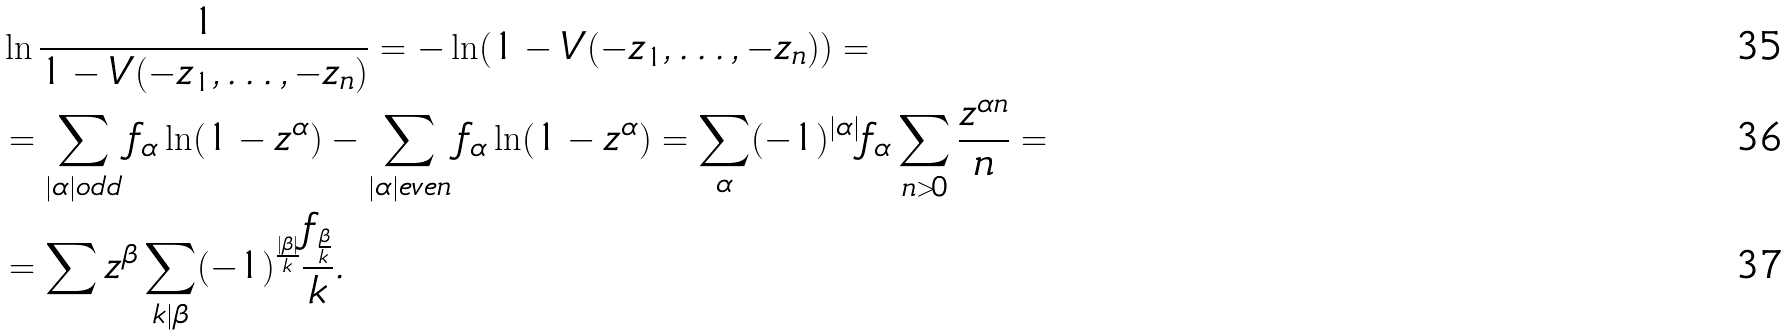Convert formula to latex. <formula><loc_0><loc_0><loc_500><loc_500>& \ln \frac { 1 } { 1 - V ( - z _ { 1 } , \dots , - z _ { n } ) } = - \ln ( 1 - V ( - z _ { 1 } , \dots , - z _ { n } ) ) = \\ & = \sum _ { | \alpha | o d d } f _ { \alpha } \ln ( 1 - z ^ { \alpha } ) - \sum _ { | \alpha | e v e n } f _ { \alpha } \ln ( 1 - z ^ { \alpha } ) = \sum _ { \alpha } ( - 1 ) ^ { | \alpha | } f _ { \alpha } \sum _ { n > 0 } \frac { z ^ { \alpha n } } { n } = \\ & = \sum z ^ { \beta } \sum _ { k | \beta } ( - 1 ) ^ { \frac { | \beta | } { k } } \frac { f _ { \frac { \beta } { k } } } { k } .</formula> 